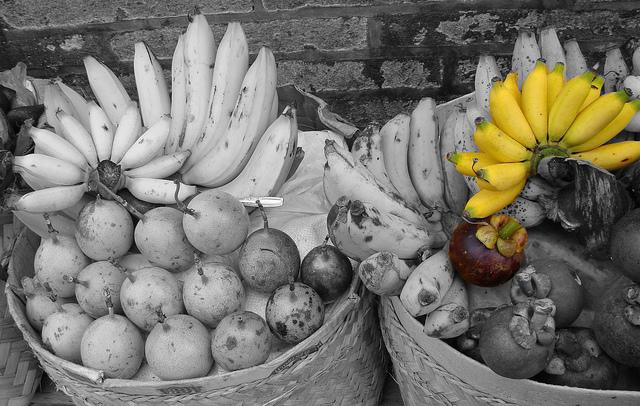Why are the bananas different colors?
Quick response, please. Photoshop. Are these food items?
Be succinct. Yes. What are the colored fruits?
Give a very brief answer. Bananas. Are the fruits white?
Keep it brief. No. Are they on sale?
Be succinct. No. 